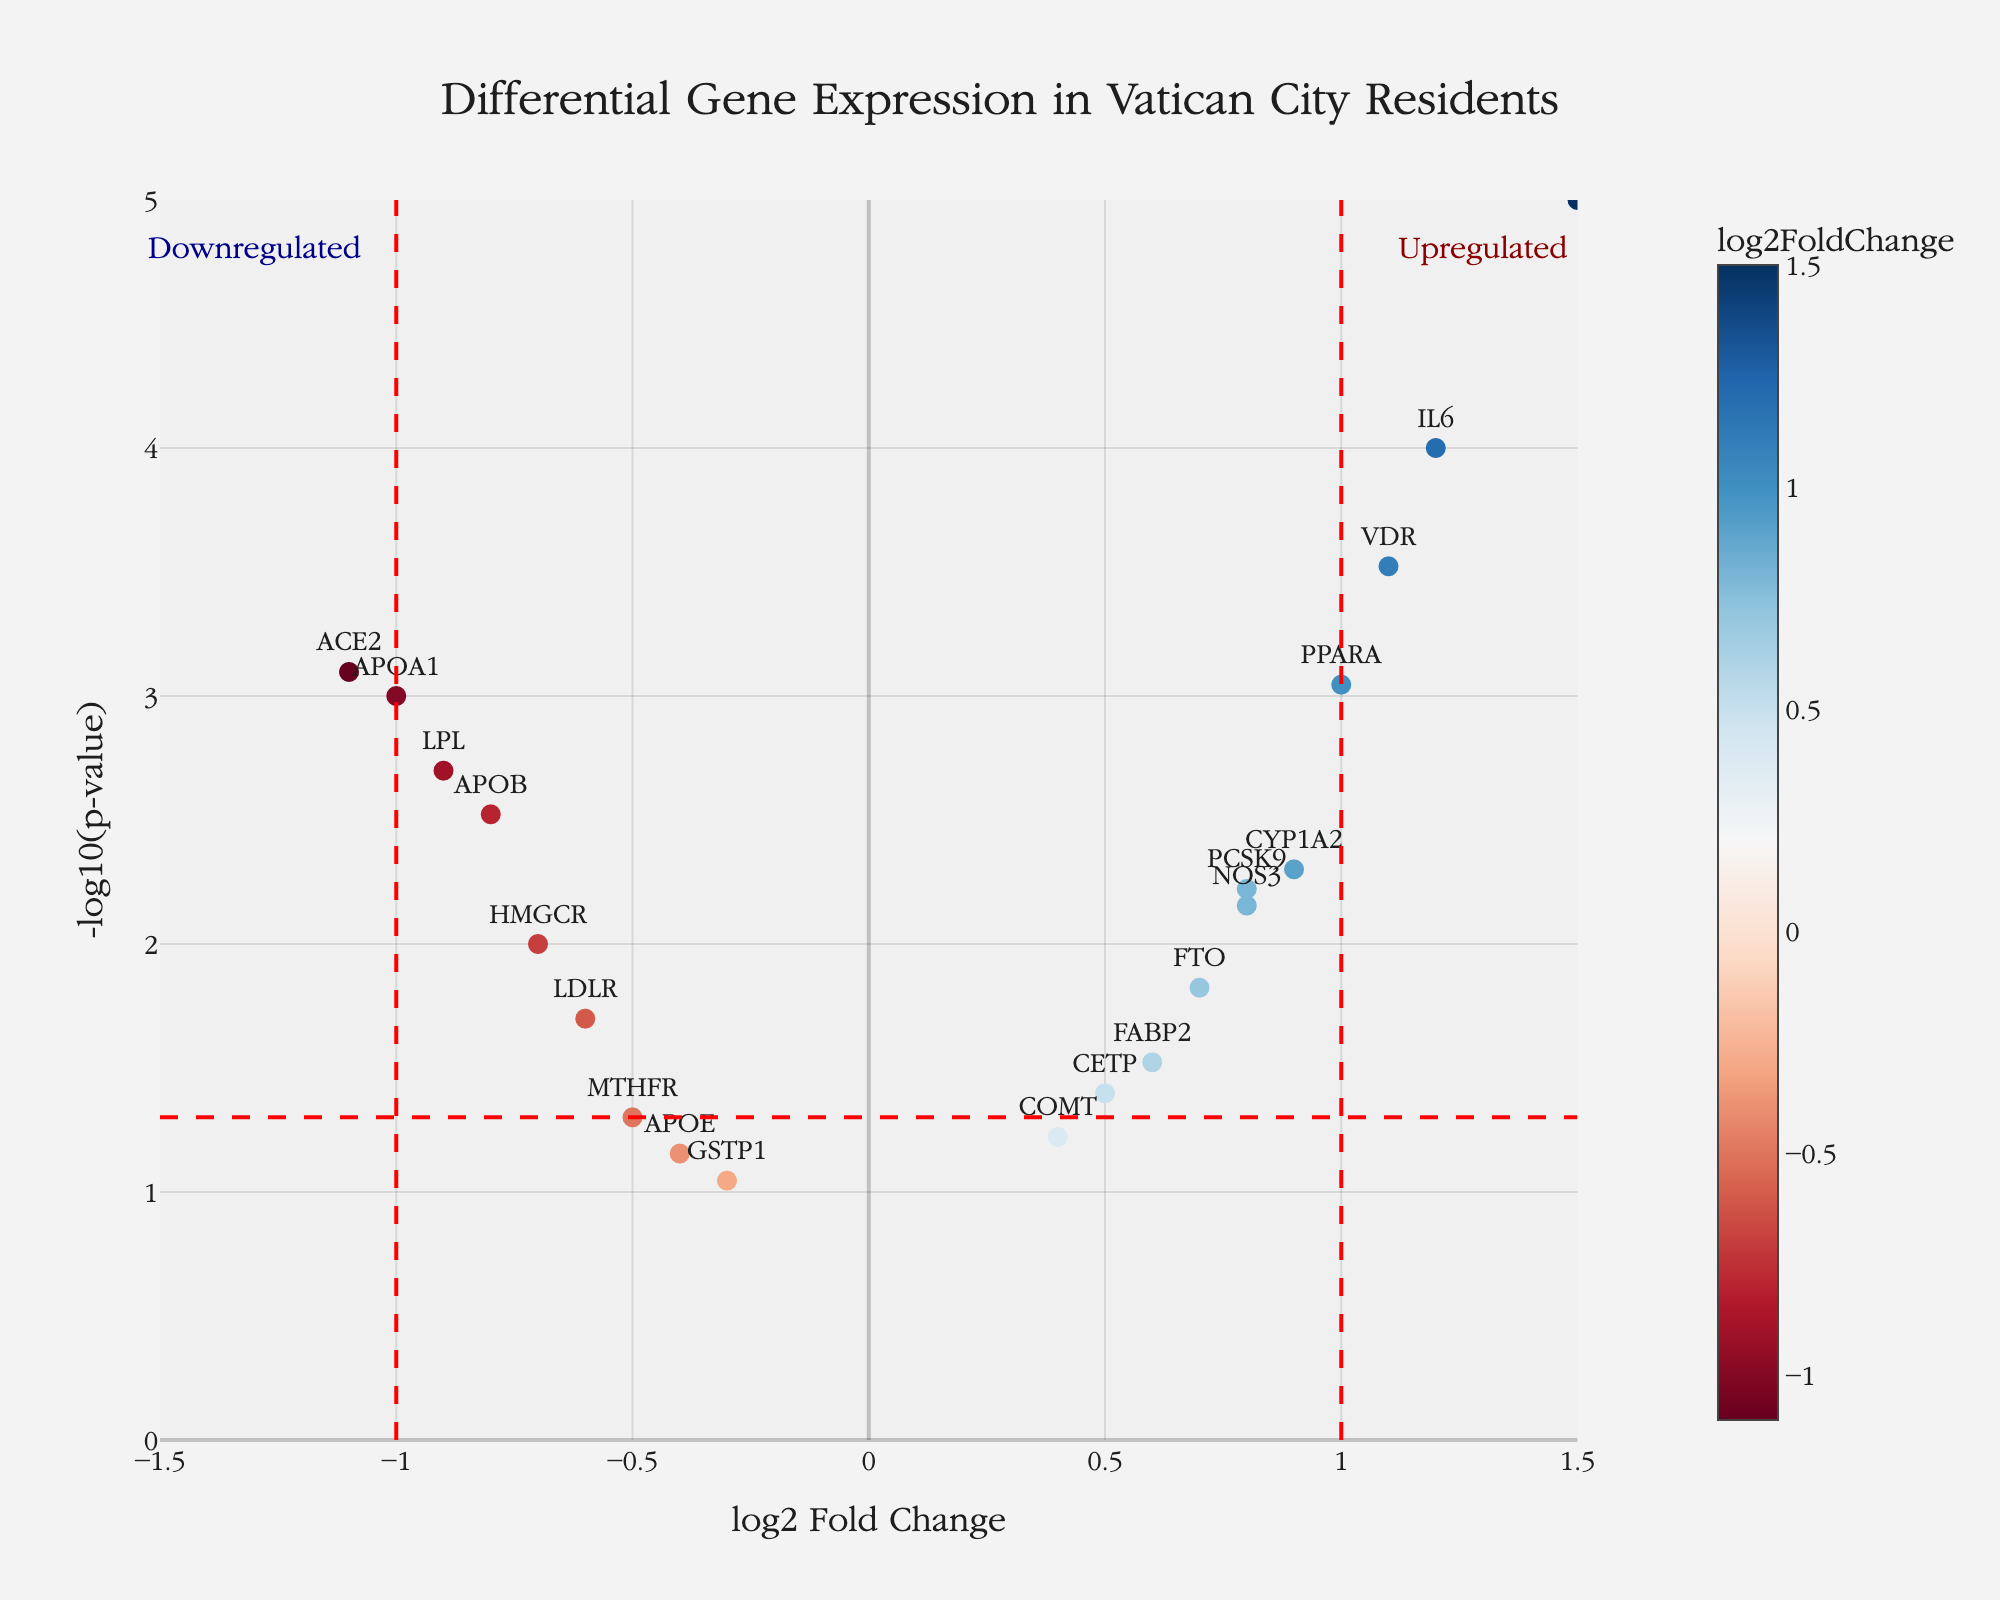How many genes are labeled as upregulated? Upregulated genes have log2 Fold Change (log2FC) values greater than 1. These genes are IL6, TNF, and VDR, so there are 3 upregulated genes.
Answer: 3 Which gene has the highest log2 Fold Change? The gene with the highest log2 Fold Change among the values is TNF with a log2 Fold Change of 1.5.
Answer: TNF What is the p-value threshold used to signify significance? The p-value threshold for significance is represented by the dashed horizontal red line, which corresponds to a p-value of 0.05.
Answer: 0.05 Which gene shows the lowest p-value, and what is its significance? By observing the y-axis values which represent -log10(p-value), the gene with the highest value indicates the lowest p-value. TNF has the highest -log10(p-value), indicating it has the lowest p-value.
Answer: TNF How many genes are downregulated? Downregulated genes have log2 Fold Change (log2FC) values less than -1. These genes are ACE2, APOA1, and LPL, so there are 3 downregulated genes.
Answer: 3 Which gene has a log2FC of 0.8 but different p-values? The gene with a log2FC of 0.8 listed in the dataset is PCSK9 and NOS3 with their respective p-values, 0.006 and 0.007.
Answer: PCSK9, NOS3 What is the range of -log10(p-value) shown on the y-axis? The y-axis ranges of the -log10(p-value) are from 0 to 5 based on the axis values.
Answer: 0 to 5 How many genes have a p-value less than or equal to 0.01? Observing the y-axis, the corresponding -log10(p-value) of 0.01 is 2. There are nine genes with values above 2 (p-value ≤ 0.01): APOB, IL6, TNF, ACE2, PPARA, VDR, LDLR, APOA1, LPL, and PCSK9.
Answer: 10 Which gene shows the highest log2 Fold Change and is significant (p-value < 0.05)? The highest log2 Fold Change value is 1.5, which corresponds to TNF. It is located above the threshold, indicating significance (p-value < 0.05).
Answer: TNF 